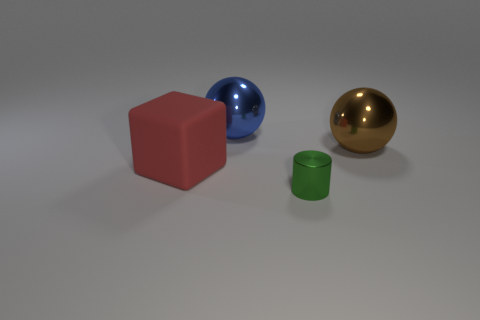Add 2 purple objects. How many objects exist? 6 Subtract all cylinders. How many objects are left? 3 Subtract 0 blue cylinders. How many objects are left? 4 Subtract all yellow rubber blocks. Subtract all small green metallic cylinders. How many objects are left? 3 Add 4 balls. How many balls are left? 6 Add 3 big red matte blocks. How many big red matte blocks exist? 4 